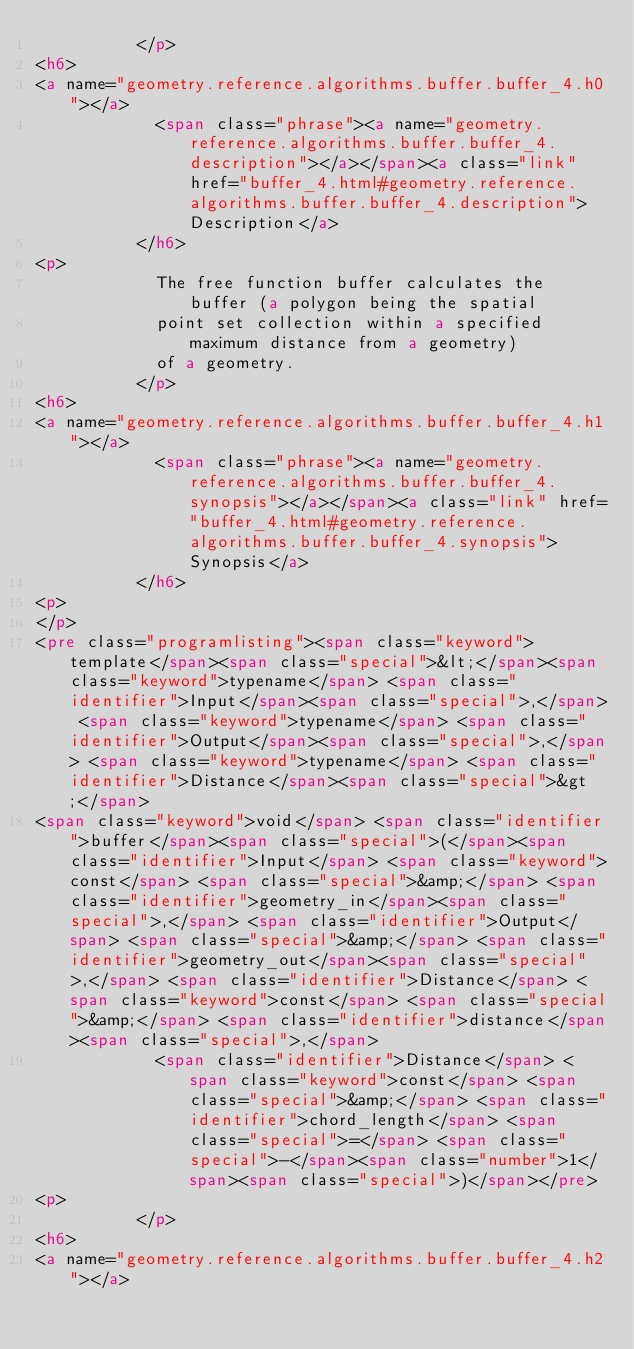Convert code to text. <code><loc_0><loc_0><loc_500><loc_500><_HTML_>          </p>
<h6>
<a name="geometry.reference.algorithms.buffer.buffer_4.h0"></a>
            <span class="phrase"><a name="geometry.reference.algorithms.buffer.buffer_4.description"></a></span><a class="link" href="buffer_4.html#geometry.reference.algorithms.buffer.buffer_4.description">Description</a>
          </h6>
<p>
            The free function buffer calculates the buffer (a polygon being the spatial
            point set collection within a specified maximum distance from a geometry)
            of a geometry.
          </p>
<h6>
<a name="geometry.reference.algorithms.buffer.buffer_4.h1"></a>
            <span class="phrase"><a name="geometry.reference.algorithms.buffer.buffer_4.synopsis"></a></span><a class="link" href="buffer_4.html#geometry.reference.algorithms.buffer.buffer_4.synopsis">Synopsis</a>
          </h6>
<p>
</p>
<pre class="programlisting"><span class="keyword">template</span><span class="special">&lt;</span><span class="keyword">typename</span> <span class="identifier">Input</span><span class="special">,</span> <span class="keyword">typename</span> <span class="identifier">Output</span><span class="special">,</span> <span class="keyword">typename</span> <span class="identifier">Distance</span><span class="special">&gt;</span>
<span class="keyword">void</span> <span class="identifier">buffer</span><span class="special">(</span><span class="identifier">Input</span> <span class="keyword">const</span> <span class="special">&amp;</span> <span class="identifier">geometry_in</span><span class="special">,</span> <span class="identifier">Output</span> <span class="special">&amp;</span> <span class="identifier">geometry_out</span><span class="special">,</span> <span class="identifier">Distance</span> <span class="keyword">const</span> <span class="special">&amp;</span> <span class="identifier">distance</span><span class="special">,</span>
            <span class="identifier">Distance</span> <span class="keyword">const</span> <span class="special">&amp;</span> <span class="identifier">chord_length</span> <span class="special">=</span> <span class="special">-</span><span class="number">1</span><span class="special">)</span></pre>
<p>
          </p>
<h6>
<a name="geometry.reference.algorithms.buffer.buffer_4.h2"></a></code> 